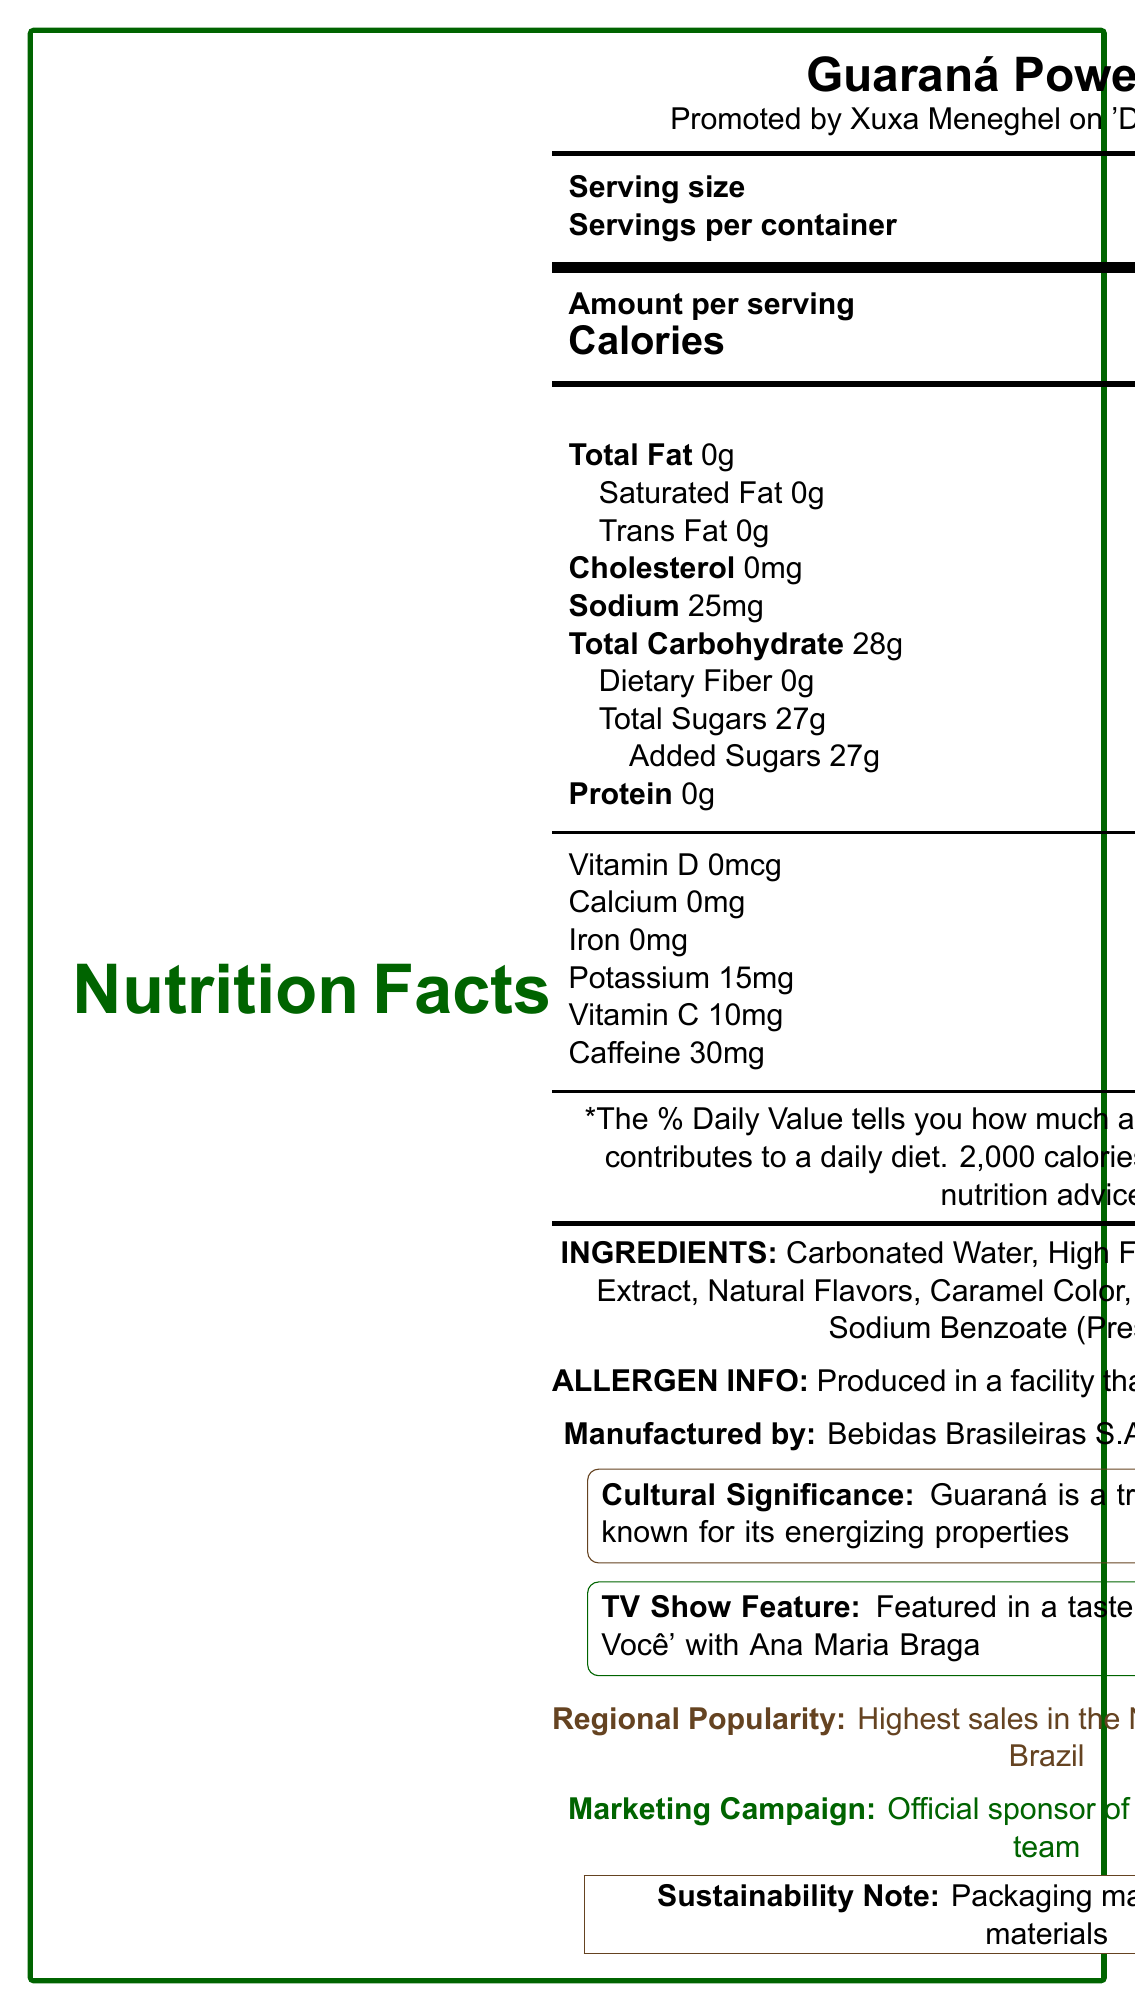what is the serving size? The serving size is clearly listed as 240 mL (1 cup) in the document.
Answer: 240 mL (1 cup) What is the brand name of the soft drink? The product name "Guaraná Power Blast" is mentioned at the top of the document.
Answer: Guaraná Power Blast How many servings are in a container? The document lists "Servings per container" as 2.5.
Answer: 2.5 Who is the celebrity endorsing this product? The document mentions that the drink is promoted by Xuxa Meneghel on 'Domingão do Faustão'.
Answer: Xuxa Meneghel How much caffeine is in one serving? The caffeine content per serving is listed as 30 mg in the document.
Answer: 30 mg Which of the following is an ingredient in Guaraná Power Blast? A. Citric Acid B. High Fructose Corn Syrup C. Sugar D. Salt The document lists High Fructose Corn Syrup as one of the ingredients.
Answer: B What percentage of the daily value of added sugars does one serving contain? A. 27% B. 54% C. 75% D. 100% Added sugars are listed as 27g which equals 54% of the daily value.
Answer: B Is this drink produced in a facility that handles allergens like soy and nuts? The document states that the drink is produced in a facility that also processes soy and nuts.
Answer: Yes Which TV show featured this product in a taste test segment? The document mentions it was featured in a taste test segment on 'Mais Você' with Ana Maria Braga.
Answer: 'Mais Você' with Ana Maria Braga What is the flavor profile of this drink? The document does not describe the specific flavor profile.
Answer: Not enough information Summarize the key nutritional facts and promotional details of the document. The document provides detailed nutrition facts, highlights the celebrity endorsement, lists ingredients, and mentions the product's cultural and regional significance, including sustainability efforts and TV show features.
Answer: Guaraná Power Blast is a Brazilian soft drink promoted by Xuxa Meneghel. It contains 110 calories per 240 mL serving with high sugar content (27g). It has no fat, protein, or Vitamin D, but includes 30 mg of caffeine and 11% of the daily value for Vitamin C. It is produced in Manaus, Amazonas, by Bebidas Brasileiras S.A. and is valued for its energizing properties due to the Guaraná extract. The drink has been highlighted on various TV shows and is notable for its high regional popularity and eco-friendly packaging. 